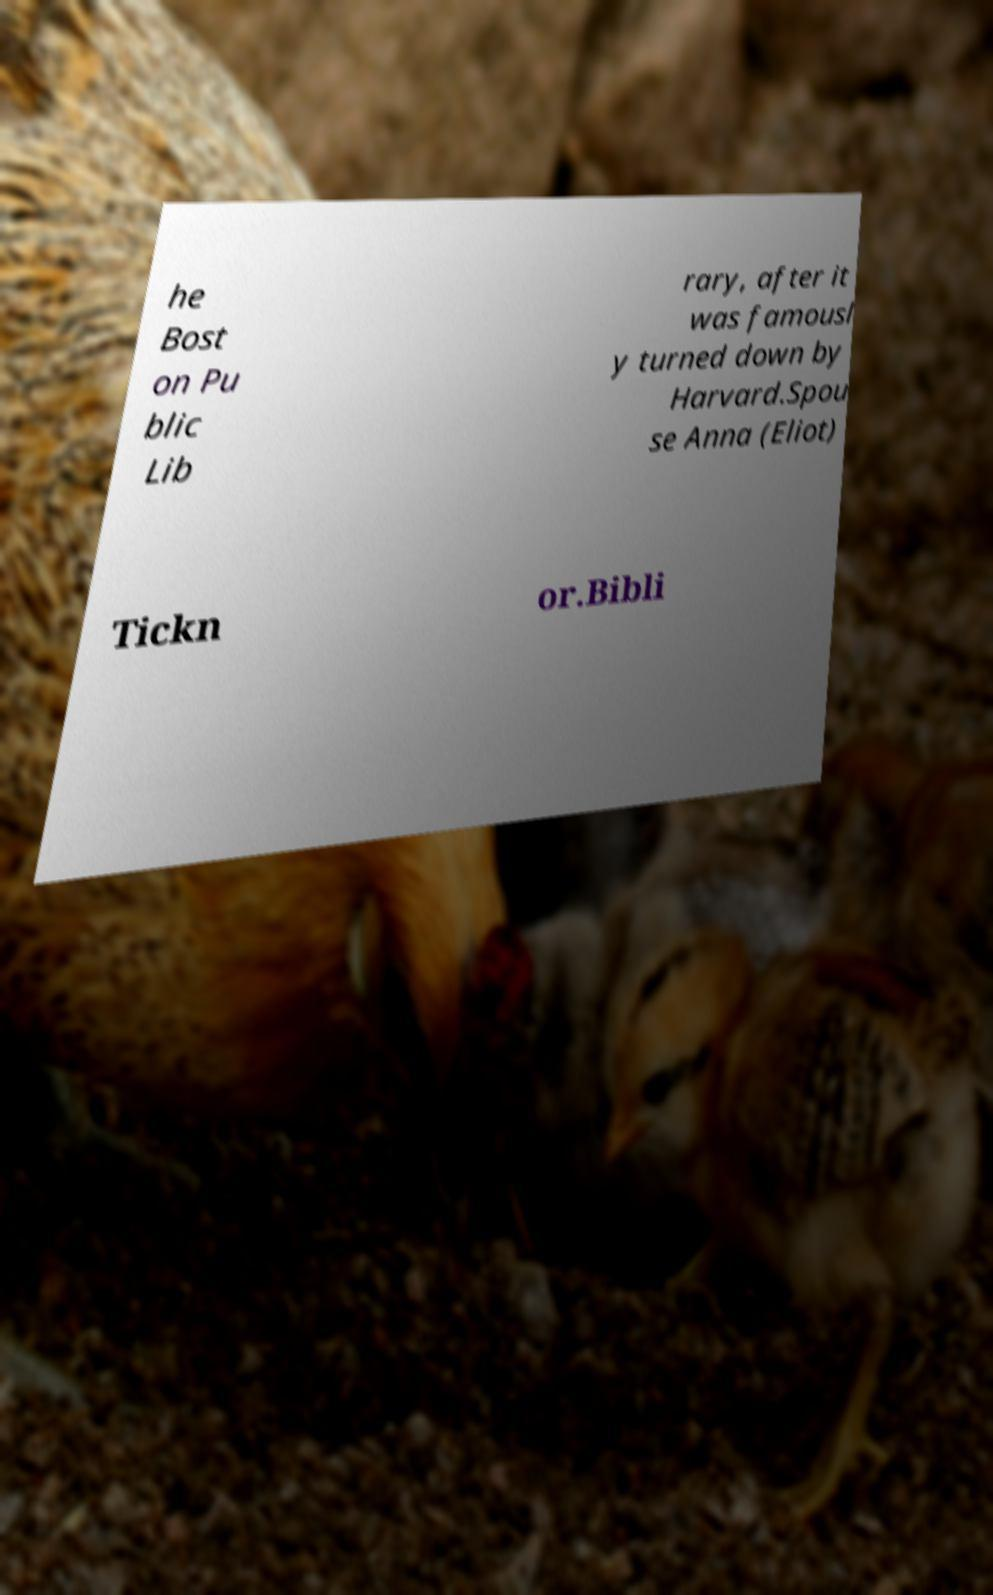Please read and relay the text visible in this image. What does it say? he Bost on Pu blic Lib rary, after it was famousl y turned down by Harvard.Spou se Anna (Eliot) Tickn or.Bibli 